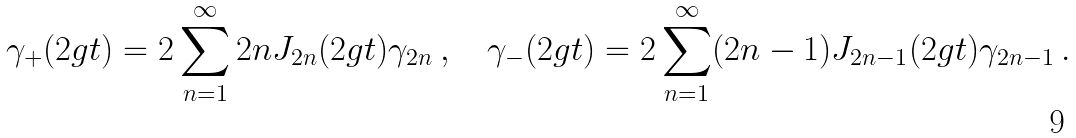<formula> <loc_0><loc_0><loc_500><loc_500>\gamma _ { + } ( 2 g t ) = 2 \sum _ { n = 1 } ^ { \infty } 2 n J _ { 2 n } ( 2 g t ) \gamma _ { 2 n } \, , \quad \gamma _ { - } ( 2 g t ) = 2 \sum _ { n = 1 } ^ { \infty } ( 2 n - 1 ) J _ { 2 n - 1 } ( 2 g t ) \gamma _ { 2 n - 1 } \, .</formula> 